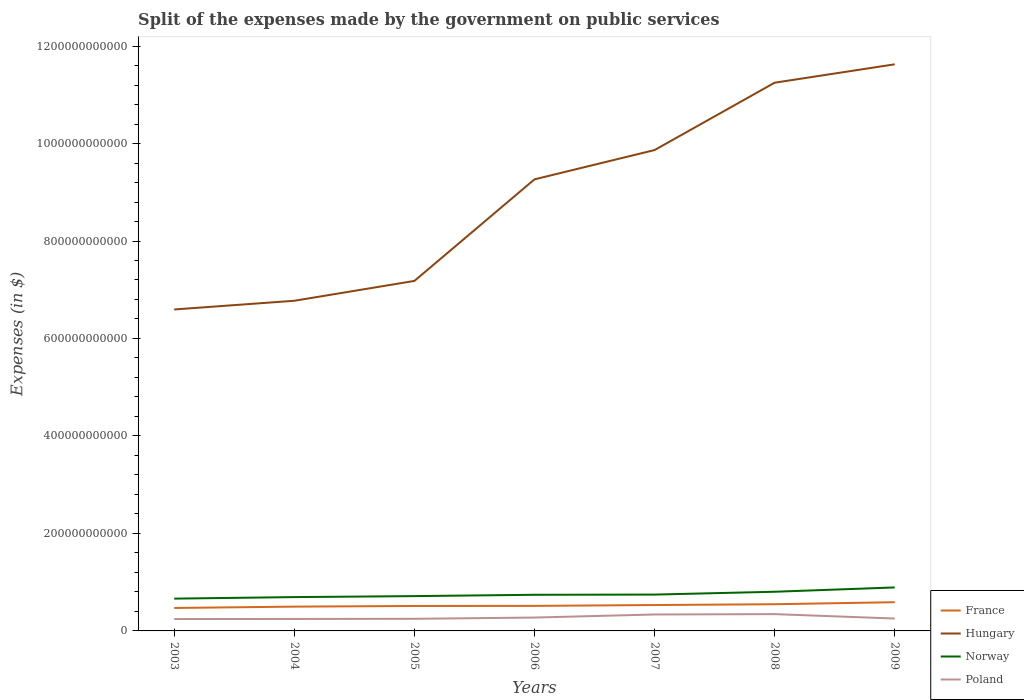Does the line corresponding to Norway intersect with the line corresponding to France?
Your answer should be compact. No. Is the number of lines equal to the number of legend labels?
Your answer should be compact. Yes. Across all years, what is the maximum expenses made by the government on public services in Hungary?
Your response must be concise. 6.60e+11. In which year was the expenses made by the government on public services in Hungary maximum?
Your answer should be very brief. 2003. What is the total expenses made by the government on public services in Poland in the graph?
Ensure brevity in your answer.  -9.18e+09. What is the difference between the highest and the second highest expenses made by the government on public services in France?
Your answer should be very brief. 1.18e+1. What is the difference between the highest and the lowest expenses made by the government on public services in Poland?
Your answer should be very brief. 2. Is the expenses made by the government on public services in Hungary strictly greater than the expenses made by the government on public services in France over the years?
Offer a very short reply. No. What is the difference between two consecutive major ticks on the Y-axis?
Offer a very short reply. 2.00e+11. Does the graph contain any zero values?
Provide a short and direct response. No. Does the graph contain grids?
Provide a short and direct response. No. Where does the legend appear in the graph?
Give a very brief answer. Bottom right. How many legend labels are there?
Your response must be concise. 4. What is the title of the graph?
Give a very brief answer. Split of the expenses made by the government on public services. What is the label or title of the X-axis?
Your response must be concise. Years. What is the label or title of the Y-axis?
Keep it short and to the point. Expenses (in $). What is the Expenses (in $) in France in 2003?
Ensure brevity in your answer.  4.71e+1. What is the Expenses (in $) of Hungary in 2003?
Provide a short and direct response. 6.60e+11. What is the Expenses (in $) of Norway in 2003?
Keep it short and to the point. 6.63e+1. What is the Expenses (in $) of Poland in 2003?
Ensure brevity in your answer.  2.44e+1. What is the Expenses (in $) in France in 2004?
Your answer should be very brief. 4.99e+1. What is the Expenses (in $) in Hungary in 2004?
Make the answer very short. 6.77e+11. What is the Expenses (in $) of Norway in 2004?
Ensure brevity in your answer.  6.94e+1. What is the Expenses (in $) in Poland in 2004?
Ensure brevity in your answer.  2.46e+1. What is the Expenses (in $) in France in 2005?
Give a very brief answer. 5.12e+1. What is the Expenses (in $) in Hungary in 2005?
Provide a succinct answer. 7.18e+11. What is the Expenses (in $) in Norway in 2005?
Ensure brevity in your answer.  7.14e+1. What is the Expenses (in $) in Poland in 2005?
Give a very brief answer. 2.49e+1. What is the Expenses (in $) in France in 2006?
Your response must be concise. 5.14e+1. What is the Expenses (in $) of Hungary in 2006?
Offer a terse response. 9.26e+11. What is the Expenses (in $) in Norway in 2006?
Provide a succinct answer. 7.42e+1. What is the Expenses (in $) of Poland in 2006?
Your answer should be compact. 2.74e+1. What is the Expenses (in $) in France in 2007?
Make the answer very short. 5.31e+1. What is the Expenses (in $) of Hungary in 2007?
Your answer should be very brief. 9.87e+11. What is the Expenses (in $) in Norway in 2007?
Your answer should be compact. 7.46e+1. What is the Expenses (in $) of Poland in 2007?
Provide a succinct answer. 3.37e+1. What is the Expenses (in $) of France in 2008?
Make the answer very short. 5.48e+1. What is the Expenses (in $) of Hungary in 2008?
Offer a terse response. 1.12e+12. What is the Expenses (in $) in Norway in 2008?
Your answer should be compact. 8.04e+1. What is the Expenses (in $) of Poland in 2008?
Offer a very short reply. 3.45e+1. What is the Expenses (in $) of France in 2009?
Offer a terse response. 5.89e+1. What is the Expenses (in $) in Hungary in 2009?
Your response must be concise. 1.16e+12. What is the Expenses (in $) of Norway in 2009?
Offer a terse response. 8.92e+1. What is the Expenses (in $) of Poland in 2009?
Give a very brief answer. 2.54e+1. Across all years, what is the maximum Expenses (in $) of France?
Provide a short and direct response. 5.89e+1. Across all years, what is the maximum Expenses (in $) of Hungary?
Give a very brief answer. 1.16e+12. Across all years, what is the maximum Expenses (in $) of Norway?
Offer a very short reply. 8.92e+1. Across all years, what is the maximum Expenses (in $) in Poland?
Make the answer very short. 3.45e+1. Across all years, what is the minimum Expenses (in $) of France?
Provide a succinct answer. 4.71e+1. Across all years, what is the minimum Expenses (in $) in Hungary?
Ensure brevity in your answer.  6.60e+11. Across all years, what is the minimum Expenses (in $) in Norway?
Ensure brevity in your answer.  6.63e+1. Across all years, what is the minimum Expenses (in $) of Poland?
Provide a short and direct response. 2.44e+1. What is the total Expenses (in $) in France in the graph?
Provide a succinct answer. 3.66e+11. What is the total Expenses (in $) in Hungary in the graph?
Your answer should be very brief. 6.26e+12. What is the total Expenses (in $) in Norway in the graph?
Your answer should be very brief. 5.25e+11. What is the total Expenses (in $) in Poland in the graph?
Provide a short and direct response. 1.95e+11. What is the difference between the Expenses (in $) of France in 2003 and that in 2004?
Provide a succinct answer. -2.75e+09. What is the difference between the Expenses (in $) of Hungary in 2003 and that in 2004?
Offer a very short reply. -1.79e+1. What is the difference between the Expenses (in $) of Norway in 2003 and that in 2004?
Your response must be concise. -3.13e+09. What is the difference between the Expenses (in $) of Poland in 2003 and that in 2004?
Your answer should be very brief. -1.78e+08. What is the difference between the Expenses (in $) in France in 2003 and that in 2005?
Your answer should be very brief. -4.07e+09. What is the difference between the Expenses (in $) in Hungary in 2003 and that in 2005?
Offer a very short reply. -5.86e+1. What is the difference between the Expenses (in $) in Norway in 2003 and that in 2005?
Provide a short and direct response. -5.14e+09. What is the difference between the Expenses (in $) of Poland in 2003 and that in 2005?
Ensure brevity in your answer.  -4.85e+08. What is the difference between the Expenses (in $) of France in 2003 and that in 2006?
Offer a terse response. -4.28e+09. What is the difference between the Expenses (in $) in Hungary in 2003 and that in 2006?
Offer a terse response. -2.67e+11. What is the difference between the Expenses (in $) of Norway in 2003 and that in 2006?
Offer a terse response. -7.88e+09. What is the difference between the Expenses (in $) of Poland in 2003 and that in 2006?
Offer a very short reply. -3.08e+09. What is the difference between the Expenses (in $) in France in 2003 and that in 2007?
Ensure brevity in your answer.  -6.01e+09. What is the difference between the Expenses (in $) in Hungary in 2003 and that in 2007?
Ensure brevity in your answer.  -3.27e+11. What is the difference between the Expenses (in $) of Norway in 2003 and that in 2007?
Ensure brevity in your answer.  -8.30e+09. What is the difference between the Expenses (in $) in Poland in 2003 and that in 2007?
Your response must be concise. -9.36e+09. What is the difference between the Expenses (in $) of France in 2003 and that in 2008?
Provide a succinct answer. -7.69e+09. What is the difference between the Expenses (in $) of Hungary in 2003 and that in 2008?
Give a very brief answer. -4.65e+11. What is the difference between the Expenses (in $) in Norway in 2003 and that in 2008?
Provide a short and direct response. -1.41e+1. What is the difference between the Expenses (in $) of Poland in 2003 and that in 2008?
Give a very brief answer. -1.01e+1. What is the difference between the Expenses (in $) of France in 2003 and that in 2009?
Your answer should be very brief. -1.18e+1. What is the difference between the Expenses (in $) in Hungary in 2003 and that in 2009?
Offer a very short reply. -5.03e+11. What is the difference between the Expenses (in $) of Norway in 2003 and that in 2009?
Your response must be concise. -2.30e+1. What is the difference between the Expenses (in $) in Poland in 2003 and that in 2009?
Provide a succinct answer. -1.05e+09. What is the difference between the Expenses (in $) in France in 2004 and that in 2005?
Ensure brevity in your answer.  -1.32e+09. What is the difference between the Expenses (in $) of Hungary in 2004 and that in 2005?
Offer a terse response. -4.07e+1. What is the difference between the Expenses (in $) of Norway in 2004 and that in 2005?
Provide a short and direct response. -2.02e+09. What is the difference between the Expenses (in $) of Poland in 2004 and that in 2005?
Keep it short and to the point. -3.07e+08. What is the difference between the Expenses (in $) of France in 2004 and that in 2006?
Your answer should be very brief. -1.53e+09. What is the difference between the Expenses (in $) of Hungary in 2004 and that in 2006?
Offer a very short reply. -2.49e+11. What is the difference between the Expenses (in $) in Norway in 2004 and that in 2006?
Your response must be concise. -4.76e+09. What is the difference between the Expenses (in $) of Poland in 2004 and that in 2006?
Provide a short and direct response. -2.90e+09. What is the difference between the Expenses (in $) in France in 2004 and that in 2007?
Make the answer very short. -3.26e+09. What is the difference between the Expenses (in $) in Hungary in 2004 and that in 2007?
Give a very brief answer. -3.09e+11. What is the difference between the Expenses (in $) in Norway in 2004 and that in 2007?
Offer a very short reply. -5.18e+09. What is the difference between the Expenses (in $) of Poland in 2004 and that in 2007?
Make the answer very short. -9.18e+09. What is the difference between the Expenses (in $) of France in 2004 and that in 2008?
Provide a succinct answer. -4.94e+09. What is the difference between the Expenses (in $) of Hungary in 2004 and that in 2008?
Ensure brevity in your answer.  -4.47e+11. What is the difference between the Expenses (in $) of Norway in 2004 and that in 2008?
Give a very brief answer. -1.10e+1. What is the difference between the Expenses (in $) of Poland in 2004 and that in 2008?
Your answer should be compact. -9.92e+09. What is the difference between the Expenses (in $) of France in 2004 and that in 2009?
Make the answer very short. -9.05e+09. What is the difference between the Expenses (in $) in Hungary in 2004 and that in 2009?
Your answer should be compact. -4.85e+11. What is the difference between the Expenses (in $) in Norway in 2004 and that in 2009?
Offer a very short reply. -1.98e+1. What is the difference between the Expenses (in $) of Poland in 2004 and that in 2009?
Ensure brevity in your answer.  -8.69e+08. What is the difference between the Expenses (in $) in France in 2005 and that in 2006?
Give a very brief answer. -2.12e+08. What is the difference between the Expenses (in $) in Hungary in 2005 and that in 2006?
Keep it short and to the point. -2.08e+11. What is the difference between the Expenses (in $) of Norway in 2005 and that in 2006?
Keep it short and to the point. -2.74e+09. What is the difference between the Expenses (in $) of Poland in 2005 and that in 2006?
Offer a very short reply. -2.59e+09. What is the difference between the Expenses (in $) of France in 2005 and that in 2007?
Your answer should be very brief. -1.94e+09. What is the difference between the Expenses (in $) of Hungary in 2005 and that in 2007?
Make the answer very short. -2.69e+11. What is the difference between the Expenses (in $) of Norway in 2005 and that in 2007?
Offer a terse response. -3.16e+09. What is the difference between the Expenses (in $) of Poland in 2005 and that in 2007?
Provide a short and direct response. -8.87e+09. What is the difference between the Expenses (in $) in France in 2005 and that in 2008?
Keep it short and to the point. -3.62e+09. What is the difference between the Expenses (in $) of Hungary in 2005 and that in 2008?
Make the answer very short. -4.07e+11. What is the difference between the Expenses (in $) in Norway in 2005 and that in 2008?
Offer a very short reply. -8.97e+09. What is the difference between the Expenses (in $) in Poland in 2005 and that in 2008?
Provide a succinct answer. -9.62e+09. What is the difference between the Expenses (in $) of France in 2005 and that in 2009?
Offer a terse response. -7.73e+09. What is the difference between the Expenses (in $) of Hungary in 2005 and that in 2009?
Provide a succinct answer. -4.44e+11. What is the difference between the Expenses (in $) of Norway in 2005 and that in 2009?
Make the answer very short. -1.78e+1. What is the difference between the Expenses (in $) of Poland in 2005 and that in 2009?
Ensure brevity in your answer.  -5.62e+08. What is the difference between the Expenses (in $) in France in 2006 and that in 2007?
Your answer should be compact. -1.73e+09. What is the difference between the Expenses (in $) of Hungary in 2006 and that in 2007?
Keep it short and to the point. -6.01e+1. What is the difference between the Expenses (in $) of Norway in 2006 and that in 2007?
Offer a terse response. -4.20e+08. What is the difference between the Expenses (in $) in Poland in 2006 and that in 2007?
Ensure brevity in your answer.  -6.28e+09. What is the difference between the Expenses (in $) in France in 2006 and that in 2008?
Keep it short and to the point. -3.41e+09. What is the difference between the Expenses (in $) in Hungary in 2006 and that in 2008?
Keep it short and to the point. -1.98e+11. What is the difference between the Expenses (in $) in Norway in 2006 and that in 2008?
Keep it short and to the point. -6.23e+09. What is the difference between the Expenses (in $) of Poland in 2006 and that in 2008?
Your answer should be compact. -7.02e+09. What is the difference between the Expenses (in $) of France in 2006 and that in 2009?
Offer a terse response. -7.52e+09. What is the difference between the Expenses (in $) in Hungary in 2006 and that in 2009?
Make the answer very short. -2.36e+11. What is the difference between the Expenses (in $) of Norway in 2006 and that in 2009?
Provide a short and direct response. -1.51e+1. What is the difference between the Expenses (in $) of Poland in 2006 and that in 2009?
Your response must be concise. 2.03e+09. What is the difference between the Expenses (in $) of France in 2007 and that in 2008?
Your answer should be compact. -1.68e+09. What is the difference between the Expenses (in $) in Hungary in 2007 and that in 2008?
Ensure brevity in your answer.  -1.38e+11. What is the difference between the Expenses (in $) of Norway in 2007 and that in 2008?
Your response must be concise. -5.81e+09. What is the difference between the Expenses (in $) of Poland in 2007 and that in 2008?
Your answer should be very brief. -7.43e+08. What is the difference between the Expenses (in $) in France in 2007 and that in 2009?
Make the answer very short. -5.79e+09. What is the difference between the Expenses (in $) in Hungary in 2007 and that in 2009?
Offer a very short reply. -1.76e+11. What is the difference between the Expenses (in $) of Norway in 2007 and that in 2009?
Offer a very short reply. -1.47e+1. What is the difference between the Expenses (in $) in Poland in 2007 and that in 2009?
Offer a terse response. 8.31e+09. What is the difference between the Expenses (in $) of France in 2008 and that in 2009?
Offer a very short reply. -4.11e+09. What is the difference between the Expenses (in $) in Hungary in 2008 and that in 2009?
Provide a short and direct response. -3.77e+1. What is the difference between the Expenses (in $) of Norway in 2008 and that in 2009?
Offer a terse response. -8.85e+09. What is the difference between the Expenses (in $) in Poland in 2008 and that in 2009?
Your answer should be compact. 9.05e+09. What is the difference between the Expenses (in $) in France in 2003 and the Expenses (in $) in Hungary in 2004?
Your answer should be compact. -6.30e+11. What is the difference between the Expenses (in $) of France in 2003 and the Expenses (in $) of Norway in 2004?
Your answer should be very brief. -2.23e+1. What is the difference between the Expenses (in $) in France in 2003 and the Expenses (in $) in Poland in 2004?
Offer a very short reply. 2.26e+1. What is the difference between the Expenses (in $) of Hungary in 2003 and the Expenses (in $) of Norway in 2004?
Offer a terse response. 5.90e+11. What is the difference between the Expenses (in $) of Hungary in 2003 and the Expenses (in $) of Poland in 2004?
Provide a short and direct response. 6.35e+11. What is the difference between the Expenses (in $) of Norway in 2003 and the Expenses (in $) of Poland in 2004?
Provide a short and direct response. 4.17e+1. What is the difference between the Expenses (in $) in France in 2003 and the Expenses (in $) in Hungary in 2005?
Offer a terse response. -6.71e+11. What is the difference between the Expenses (in $) of France in 2003 and the Expenses (in $) of Norway in 2005?
Your response must be concise. -2.43e+1. What is the difference between the Expenses (in $) in France in 2003 and the Expenses (in $) in Poland in 2005?
Your answer should be compact. 2.22e+1. What is the difference between the Expenses (in $) in Hungary in 2003 and the Expenses (in $) in Norway in 2005?
Your response must be concise. 5.88e+11. What is the difference between the Expenses (in $) of Hungary in 2003 and the Expenses (in $) of Poland in 2005?
Your answer should be very brief. 6.35e+11. What is the difference between the Expenses (in $) in Norway in 2003 and the Expenses (in $) in Poland in 2005?
Provide a succinct answer. 4.14e+1. What is the difference between the Expenses (in $) in France in 2003 and the Expenses (in $) in Hungary in 2006?
Give a very brief answer. -8.79e+11. What is the difference between the Expenses (in $) in France in 2003 and the Expenses (in $) in Norway in 2006?
Keep it short and to the point. -2.70e+1. What is the difference between the Expenses (in $) of France in 2003 and the Expenses (in $) of Poland in 2006?
Make the answer very short. 1.97e+1. What is the difference between the Expenses (in $) in Hungary in 2003 and the Expenses (in $) in Norway in 2006?
Keep it short and to the point. 5.85e+11. What is the difference between the Expenses (in $) of Hungary in 2003 and the Expenses (in $) of Poland in 2006?
Your response must be concise. 6.32e+11. What is the difference between the Expenses (in $) in Norway in 2003 and the Expenses (in $) in Poland in 2006?
Provide a short and direct response. 3.88e+1. What is the difference between the Expenses (in $) of France in 2003 and the Expenses (in $) of Hungary in 2007?
Provide a succinct answer. -9.39e+11. What is the difference between the Expenses (in $) of France in 2003 and the Expenses (in $) of Norway in 2007?
Make the answer very short. -2.75e+1. What is the difference between the Expenses (in $) in France in 2003 and the Expenses (in $) in Poland in 2007?
Make the answer very short. 1.34e+1. What is the difference between the Expenses (in $) of Hungary in 2003 and the Expenses (in $) of Norway in 2007?
Offer a very short reply. 5.85e+11. What is the difference between the Expenses (in $) of Hungary in 2003 and the Expenses (in $) of Poland in 2007?
Ensure brevity in your answer.  6.26e+11. What is the difference between the Expenses (in $) of Norway in 2003 and the Expenses (in $) of Poland in 2007?
Your answer should be very brief. 3.25e+1. What is the difference between the Expenses (in $) in France in 2003 and the Expenses (in $) in Hungary in 2008?
Your response must be concise. -1.08e+12. What is the difference between the Expenses (in $) in France in 2003 and the Expenses (in $) in Norway in 2008?
Ensure brevity in your answer.  -3.33e+1. What is the difference between the Expenses (in $) in France in 2003 and the Expenses (in $) in Poland in 2008?
Your answer should be compact. 1.26e+1. What is the difference between the Expenses (in $) of Hungary in 2003 and the Expenses (in $) of Norway in 2008?
Your response must be concise. 5.79e+11. What is the difference between the Expenses (in $) in Hungary in 2003 and the Expenses (in $) in Poland in 2008?
Your answer should be compact. 6.25e+11. What is the difference between the Expenses (in $) of Norway in 2003 and the Expenses (in $) of Poland in 2008?
Your answer should be very brief. 3.18e+1. What is the difference between the Expenses (in $) in France in 2003 and the Expenses (in $) in Hungary in 2009?
Your response must be concise. -1.12e+12. What is the difference between the Expenses (in $) in France in 2003 and the Expenses (in $) in Norway in 2009?
Your answer should be very brief. -4.21e+1. What is the difference between the Expenses (in $) in France in 2003 and the Expenses (in $) in Poland in 2009?
Provide a short and direct response. 2.17e+1. What is the difference between the Expenses (in $) of Hungary in 2003 and the Expenses (in $) of Norway in 2009?
Give a very brief answer. 5.70e+11. What is the difference between the Expenses (in $) in Hungary in 2003 and the Expenses (in $) in Poland in 2009?
Ensure brevity in your answer.  6.34e+11. What is the difference between the Expenses (in $) of Norway in 2003 and the Expenses (in $) of Poland in 2009?
Your answer should be compact. 4.08e+1. What is the difference between the Expenses (in $) of France in 2004 and the Expenses (in $) of Hungary in 2005?
Keep it short and to the point. -6.68e+11. What is the difference between the Expenses (in $) of France in 2004 and the Expenses (in $) of Norway in 2005?
Provide a short and direct response. -2.16e+1. What is the difference between the Expenses (in $) in France in 2004 and the Expenses (in $) in Poland in 2005?
Make the answer very short. 2.50e+1. What is the difference between the Expenses (in $) of Hungary in 2004 and the Expenses (in $) of Norway in 2005?
Ensure brevity in your answer.  6.06e+11. What is the difference between the Expenses (in $) in Hungary in 2004 and the Expenses (in $) in Poland in 2005?
Provide a short and direct response. 6.53e+11. What is the difference between the Expenses (in $) in Norway in 2004 and the Expenses (in $) in Poland in 2005?
Make the answer very short. 4.45e+1. What is the difference between the Expenses (in $) in France in 2004 and the Expenses (in $) in Hungary in 2006?
Ensure brevity in your answer.  -8.77e+11. What is the difference between the Expenses (in $) in France in 2004 and the Expenses (in $) in Norway in 2006?
Keep it short and to the point. -2.43e+1. What is the difference between the Expenses (in $) of France in 2004 and the Expenses (in $) of Poland in 2006?
Provide a succinct answer. 2.24e+1. What is the difference between the Expenses (in $) in Hungary in 2004 and the Expenses (in $) in Norway in 2006?
Keep it short and to the point. 6.03e+11. What is the difference between the Expenses (in $) in Hungary in 2004 and the Expenses (in $) in Poland in 2006?
Give a very brief answer. 6.50e+11. What is the difference between the Expenses (in $) in Norway in 2004 and the Expenses (in $) in Poland in 2006?
Ensure brevity in your answer.  4.19e+1. What is the difference between the Expenses (in $) in France in 2004 and the Expenses (in $) in Hungary in 2007?
Your answer should be very brief. -9.37e+11. What is the difference between the Expenses (in $) in France in 2004 and the Expenses (in $) in Norway in 2007?
Your response must be concise. -2.47e+1. What is the difference between the Expenses (in $) of France in 2004 and the Expenses (in $) of Poland in 2007?
Your answer should be compact. 1.61e+1. What is the difference between the Expenses (in $) of Hungary in 2004 and the Expenses (in $) of Norway in 2007?
Keep it short and to the point. 6.03e+11. What is the difference between the Expenses (in $) of Hungary in 2004 and the Expenses (in $) of Poland in 2007?
Make the answer very short. 6.44e+11. What is the difference between the Expenses (in $) of Norway in 2004 and the Expenses (in $) of Poland in 2007?
Your answer should be compact. 3.57e+1. What is the difference between the Expenses (in $) in France in 2004 and the Expenses (in $) in Hungary in 2008?
Offer a very short reply. -1.07e+12. What is the difference between the Expenses (in $) of France in 2004 and the Expenses (in $) of Norway in 2008?
Provide a short and direct response. -3.05e+1. What is the difference between the Expenses (in $) in France in 2004 and the Expenses (in $) in Poland in 2008?
Give a very brief answer. 1.54e+1. What is the difference between the Expenses (in $) in Hungary in 2004 and the Expenses (in $) in Norway in 2008?
Offer a very short reply. 5.97e+11. What is the difference between the Expenses (in $) in Hungary in 2004 and the Expenses (in $) in Poland in 2008?
Provide a succinct answer. 6.43e+11. What is the difference between the Expenses (in $) of Norway in 2004 and the Expenses (in $) of Poland in 2008?
Provide a succinct answer. 3.49e+1. What is the difference between the Expenses (in $) of France in 2004 and the Expenses (in $) of Hungary in 2009?
Give a very brief answer. -1.11e+12. What is the difference between the Expenses (in $) of France in 2004 and the Expenses (in $) of Norway in 2009?
Offer a terse response. -3.94e+1. What is the difference between the Expenses (in $) of France in 2004 and the Expenses (in $) of Poland in 2009?
Give a very brief answer. 2.44e+1. What is the difference between the Expenses (in $) in Hungary in 2004 and the Expenses (in $) in Norway in 2009?
Ensure brevity in your answer.  5.88e+11. What is the difference between the Expenses (in $) of Hungary in 2004 and the Expenses (in $) of Poland in 2009?
Offer a terse response. 6.52e+11. What is the difference between the Expenses (in $) of Norway in 2004 and the Expenses (in $) of Poland in 2009?
Provide a succinct answer. 4.40e+1. What is the difference between the Expenses (in $) of France in 2005 and the Expenses (in $) of Hungary in 2006?
Offer a terse response. -8.75e+11. What is the difference between the Expenses (in $) in France in 2005 and the Expenses (in $) in Norway in 2006?
Offer a very short reply. -2.30e+1. What is the difference between the Expenses (in $) in France in 2005 and the Expenses (in $) in Poland in 2006?
Offer a terse response. 2.37e+1. What is the difference between the Expenses (in $) of Hungary in 2005 and the Expenses (in $) of Norway in 2006?
Provide a succinct answer. 6.44e+11. What is the difference between the Expenses (in $) of Hungary in 2005 and the Expenses (in $) of Poland in 2006?
Provide a succinct answer. 6.91e+11. What is the difference between the Expenses (in $) in Norway in 2005 and the Expenses (in $) in Poland in 2006?
Provide a succinct answer. 4.40e+1. What is the difference between the Expenses (in $) of France in 2005 and the Expenses (in $) of Hungary in 2007?
Ensure brevity in your answer.  -9.35e+11. What is the difference between the Expenses (in $) of France in 2005 and the Expenses (in $) of Norway in 2007?
Your answer should be compact. -2.34e+1. What is the difference between the Expenses (in $) in France in 2005 and the Expenses (in $) in Poland in 2007?
Your response must be concise. 1.74e+1. What is the difference between the Expenses (in $) of Hungary in 2005 and the Expenses (in $) of Norway in 2007?
Your answer should be very brief. 6.44e+11. What is the difference between the Expenses (in $) in Hungary in 2005 and the Expenses (in $) in Poland in 2007?
Give a very brief answer. 6.84e+11. What is the difference between the Expenses (in $) in Norway in 2005 and the Expenses (in $) in Poland in 2007?
Offer a terse response. 3.77e+1. What is the difference between the Expenses (in $) of France in 2005 and the Expenses (in $) of Hungary in 2008?
Offer a terse response. -1.07e+12. What is the difference between the Expenses (in $) in France in 2005 and the Expenses (in $) in Norway in 2008?
Make the answer very short. -2.92e+1. What is the difference between the Expenses (in $) of France in 2005 and the Expenses (in $) of Poland in 2008?
Make the answer very short. 1.67e+1. What is the difference between the Expenses (in $) in Hungary in 2005 and the Expenses (in $) in Norway in 2008?
Provide a succinct answer. 6.38e+11. What is the difference between the Expenses (in $) of Hungary in 2005 and the Expenses (in $) of Poland in 2008?
Offer a terse response. 6.84e+11. What is the difference between the Expenses (in $) of Norway in 2005 and the Expenses (in $) of Poland in 2008?
Offer a very short reply. 3.69e+1. What is the difference between the Expenses (in $) of France in 2005 and the Expenses (in $) of Hungary in 2009?
Offer a terse response. -1.11e+12. What is the difference between the Expenses (in $) of France in 2005 and the Expenses (in $) of Norway in 2009?
Keep it short and to the point. -3.81e+1. What is the difference between the Expenses (in $) of France in 2005 and the Expenses (in $) of Poland in 2009?
Keep it short and to the point. 2.58e+1. What is the difference between the Expenses (in $) in Hungary in 2005 and the Expenses (in $) in Norway in 2009?
Your answer should be very brief. 6.29e+11. What is the difference between the Expenses (in $) in Hungary in 2005 and the Expenses (in $) in Poland in 2009?
Your answer should be compact. 6.93e+11. What is the difference between the Expenses (in $) of Norway in 2005 and the Expenses (in $) of Poland in 2009?
Your answer should be very brief. 4.60e+1. What is the difference between the Expenses (in $) of France in 2006 and the Expenses (in $) of Hungary in 2007?
Give a very brief answer. -9.35e+11. What is the difference between the Expenses (in $) in France in 2006 and the Expenses (in $) in Norway in 2007?
Provide a succinct answer. -2.32e+1. What is the difference between the Expenses (in $) of France in 2006 and the Expenses (in $) of Poland in 2007?
Your answer should be very brief. 1.77e+1. What is the difference between the Expenses (in $) in Hungary in 2006 and the Expenses (in $) in Norway in 2007?
Your answer should be compact. 8.52e+11. What is the difference between the Expenses (in $) of Hungary in 2006 and the Expenses (in $) of Poland in 2007?
Make the answer very short. 8.93e+11. What is the difference between the Expenses (in $) of Norway in 2006 and the Expenses (in $) of Poland in 2007?
Provide a succinct answer. 4.04e+1. What is the difference between the Expenses (in $) in France in 2006 and the Expenses (in $) in Hungary in 2008?
Give a very brief answer. -1.07e+12. What is the difference between the Expenses (in $) in France in 2006 and the Expenses (in $) in Norway in 2008?
Offer a terse response. -2.90e+1. What is the difference between the Expenses (in $) of France in 2006 and the Expenses (in $) of Poland in 2008?
Provide a succinct answer. 1.69e+1. What is the difference between the Expenses (in $) in Hungary in 2006 and the Expenses (in $) in Norway in 2008?
Provide a short and direct response. 8.46e+11. What is the difference between the Expenses (in $) of Hungary in 2006 and the Expenses (in $) of Poland in 2008?
Make the answer very short. 8.92e+11. What is the difference between the Expenses (in $) in Norway in 2006 and the Expenses (in $) in Poland in 2008?
Offer a very short reply. 3.97e+1. What is the difference between the Expenses (in $) of France in 2006 and the Expenses (in $) of Hungary in 2009?
Your answer should be very brief. -1.11e+12. What is the difference between the Expenses (in $) of France in 2006 and the Expenses (in $) of Norway in 2009?
Your answer should be very brief. -3.78e+1. What is the difference between the Expenses (in $) in France in 2006 and the Expenses (in $) in Poland in 2009?
Keep it short and to the point. 2.60e+1. What is the difference between the Expenses (in $) of Hungary in 2006 and the Expenses (in $) of Norway in 2009?
Give a very brief answer. 8.37e+11. What is the difference between the Expenses (in $) in Hungary in 2006 and the Expenses (in $) in Poland in 2009?
Provide a short and direct response. 9.01e+11. What is the difference between the Expenses (in $) in Norway in 2006 and the Expenses (in $) in Poland in 2009?
Offer a terse response. 4.87e+1. What is the difference between the Expenses (in $) of France in 2007 and the Expenses (in $) of Hungary in 2008?
Ensure brevity in your answer.  -1.07e+12. What is the difference between the Expenses (in $) in France in 2007 and the Expenses (in $) in Norway in 2008?
Keep it short and to the point. -2.73e+1. What is the difference between the Expenses (in $) in France in 2007 and the Expenses (in $) in Poland in 2008?
Ensure brevity in your answer.  1.86e+1. What is the difference between the Expenses (in $) of Hungary in 2007 and the Expenses (in $) of Norway in 2008?
Keep it short and to the point. 9.06e+11. What is the difference between the Expenses (in $) of Hungary in 2007 and the Expenses (in $) of Poland in 2008?
Ensure brevity in your answer.  9.52e+11. What is the difference between the Expenses (in $) of Norway in 2007 and the Expenses (in $) of Poland in 2008?
Make the answer very short. 4.01e+1. What is the difference between the Expenses (in $) in France in 2007 and the Expenses (in $) in Hungary in 2009?
Provide a short and direct response. -1.11e+12. What is the difference between the Expenses (in $) of France in 2007 and the Expenses (in $) of Norway in 2009?
Offer a terse response. -3.61e+1. What is the difference between the Expenses (in $) in France in 2007 and the Expenses (in $) in Poland in 2009?
Your answer should be compact. 2.77e+1. What is the difference between the Expenses (in $) of Hungary in 2007 and the Expenses (in $) of Norway in 2009?
Ensure brevity in your answer.  8.97e+11. What is the difference between the Expenses (in $) in Hungary in 2007 and the Expenses (in $) in Poland in 2009?
Your answer should be compact. 9.61e+11. What is the difference between the Expenses (in $) of Norway in 2007 and the Expenses (in $) of Poland in 2009?
Ensure brevity in your answer.  4.92e+1. What is the difference between the Expenses (in $) of France in 2008 and the Expenses (in $) of Hungary in 2009?
Offer a terse response. -1.11e+12. What is the difference between the Expenses (in $) in France in 2008 and the Expenses (in $) in Norway in 2009?
Offer a very short reply. -3.44e+1. What is the difference between the Expenses (in $) in France in 2008 and the Expenses (in $) in Poland in 2009?
Offer a very short reply. 2.94e+1. What is the difference between the Expenses (in $) in Hungary in 2008 and the Expenses (in $) in Norway in 2009?
Your response must be concise. 1.04e+12. What is the difference between the Expenses (in $) in Hungary in 2008 and the Expenses (in $) in Poland in 2009?
Your answer should be compact. 1.10e+12. What is the difference between the Expenses (in $) in Norway in 2008 and the Expenses (in $) in Poland in 2009?
Give a very brief answer. 5.50e+1. What is the average Expenses (in $) of France per year?
Your answer should be very brief. 5.23e+1. What is the average Expenses (in $) in Hungary per year?
Your answer should be compact. 8.94e+11. What is the average Expenses (in $) in Norway per year?
Make the answer very short. 7.51e+1. What is the average Expenses (in $) of Poland per year?
Give a very brief answer. 2.78e+1. In the year 2003, what is the difference between the Expenses (in $) in France and Expenses (in $) in Hungary?
Offer a terse response. -6.12e+11. In the year 2003, what is the difference between the Expenses (in $) in France and Expenses (in $) in Norway?
Provide a short and direct response. -1.92e+1. In the year 2003, what is the difference between the Expenses (in $) of France and Expenses (in $) of Poland?
Offer a very short reply. 2.27e+1. In the year 2003, what is the difference between the Expenses (in $) in Hungary and Expenses (in $) in Norway?
Your answer should be compact. 5.93e+11. In the year 2003, what is the difference between the Expenses (in $) of Hungary and Expenses (in $) of Poland?
Make the answer very short. 6.35e+11. In the year 2003, what is the difference between the Expenses (in $) of Norway and Expenses (in $) of Poland?
Provide a succinct answer. 4.19e+1. In the year 2004, what is the difference between the Expenses (in $) of France and Expenses (in $) of Hungary?
Give a very brief answer. -6.28e+11. In the year 2004, what is the difference between the Expenses (in $) in France and Expenses (in $) in Norway?
Provide a short and direct response. -1.95e+1. In the year 2004, what is the difference between the Expenses (in $) of France and Expenses (in $) of Poland?
Your answer should be very brief. 2.53e+1. In the year 2004, what is the difference between the Expenses (in $) of Hungary and Expenses (in $) of Norway?
Offer a very short reply. 6.08e+11. In the year 2004, what is the difference between the Expenses (in $) of Hungary and Expenses (in $) of Poland?
Your response must be concise. 6.53e+11. In the year 2004, what is the difference between the Expenses (in $) in Norway and Expenses (in $) in Poland?
Offer a terse response. 4.48e+1. In the year 2005, what is the difference between the Expenses (in $) of France and Expenses (in $) of Hungary?
Your answer should be compact. -6.67e+11. In the year 2005, what is the difference between the Expenses (in $) of France and Expenses (in $) of Norway?
Offer a very short reply. -2.02e+1. In the year 2005, what is the difference between the Expenses (in $) of France and Expenses (in $) of Poland?
Provide a succinct answer. 2.63e+1. In the year 2005, what is the difference between the Expenses (in $) of Hungary and Expenses (in $) of Norway?
Provide a short and direct response. 6.47e+11. In the year 2005, what is the difference between the Expenses (in $) of Hungary and Expenses (in $) of Poland?
Provide a short and direct response. 6.93e+11. In the year 2005, what is the difference between the Expenses (in $) in Norway and Expenses (in $) in Poland?
Keep it short and to the point. 4.66e+1. In the year 2006, what is the difference between the Expenses (in $) of France and Expenses (in $) of Hungary?
Your response must be concise. -8.75e+11. In the year 2006, what is the difference between the Expenses (in $) in France and Expenses (in $) in Norway?
Make the answer very short. -2.28e+1. In the year 2006, what is the difference between the Expenses (in $) in France and Expenses (in $) in Poland?
Provide a succinct answer. 2.39e+1. In the year 2006, what is the difference between the Expenses (in $) in Hungary and Expenses (in $) in Norway?
Provide a short and direct response. 8.52e+11. In the year 2006, what is the difference between the Expenses (in $) in Hungary and Expenses (in $) in Poland?
Your response must be concise. 8.99e+11. In the year 2006, what is the difference between the Expenses (in $) of Norway and Expenses (in $) of Poland?
Provide a succinct answer. 4.67e+1. In the year 2007, what is the difference between the Expenses (in $) in France and Expenses (in $) in Hungary?
Offer a very short reply. -9.33e+11. In the year 2007, what is the difference between the Expenses (in $) of France and Expenses (in $) of Norway?
Your answer should be very brief. -2.15e+1. In the year 2007, what is the difference between the Expenses (in $) in France and Expenses (in $) in Poland?
Keep it short and to the point. 1.94e+1. In the year 2007, what is the difference between the Expenses (in $) in Hungary and Expenses (in $) in Norway?
Your answer should be compact. 9.12e+11. In the year 2007, what is the difference between the Expenses (in $) of Hungary and Expenses (in $) of Poland?
Your answer should be very brief. 9.53e+11. In the year 2007, what is the difference between the Expenses (in $) in Norway and Expenses (in $) in Poland?
Offer a terse response. 4.08e+1. In the year 2008, what is the difference between the Expenses (in $) of France and Expenses (in $) of Hungary?
Ensure brevity in your answer.  -1.07e+12. In the year 2008, what is the difference between the Expenses (in $) of France and Expenses (in $) of Norway?
Offer a terse response. -2.56e+1. In the year 2008, what is the difference between the Expenses (in $) of France and Expenses (in $) of Poland?
Ensure brevity in your answer.  2.03e+1. In the year 2008, what is the difference between the Expenses (in $) of Hungary and Expenses (in $) of Norway?
Keep it short and to the point. 1.04e+12. In the year 2008, what is the difference between the Expenses (in $) in Hungary and Expenses (in $) in Poland?
Offer a very short reply. 1.09e+12. In the year 2008, what is the difference between the Expenses (in $) in Norway and Expenses (in $) in Poland?
Offer a very short reply. 4.59e+1. In the year 2009, what is the difference between the Expenses (in $) of France and Expenses (in $) of Hungary?
Provide a succinct answer. -1.10e+12. In the year 2009, what is the difference between the Expenses (in $) in France and Expenses (in $) in Norway?
Your response must be concise. -3.03e+1. In the year 2009, what is the difference between the Expenses (in $) in France and Expenses (in $) in Poland?
Your response must be concise. 3.35e+1. In the year 2009, what is the difference between the Expenses (in $) in Hungary and Expenses (in $) in Norway?
Provide a succinct answer. 1.07e+12. In the year 2009, what is the difference between the Expenses (in $) in Hungary and Expenses (in $) in Poland?
Offer a very short reply. 1.14e+12. In the year 2009, what is the difference between the Expenses (in $) of Norway and Expenses (in $) of Poland?
Give a very brief answer. 6.38e+1. What is the ratio of the Expenses (in $) in France in 2003 to that in 2004?
Provide a short and direct response. 0.94. What is the ratio of the Expenses (in $) of Hungary in 2003 to that in 2004?
Provide a short and direct response. 0.97. What is the ratio of the Expenses (in $) of Norway in 2003 to that in 2004?
Offer a very short reply. 0.95. What is the ratio of the Expenses (in $) of Poland in 2003 to that in 2004?
Make the answer very short. 0.99. What is the ratio of the Expenses (in $) in France in 2003 to that in 2005?
Keep it short and to the point. 0.92. What is the ratio of the Expenses (in $) of Hungary in 2003 to that in 2005?
Your answer should be compact. 0.92. What is the ratio of the Expenses (in $) in Norway in 2003 to that in 2005?
Keep it short and to the point. 0.93. What is the ratio of the Expenses (in $) of Poland in 2003 to that in 2005?
Your answer should be very brief. 0.98. What is the ratio of the Expenses (in $) of Hungary in 2003 to that in 2006?
Offer a terse response. 0.71. What is the ratio of the Expenses (in $) of Norway in 2003 to that in 2006?
Offer a very short reply. 0.89. What is the ratio of the Expenses (in $) of Poland in 2003 to that in 2006?
Offer a very short reply. 0.89. What is the ratio of the Expenses (in $) in France in 2003 to that in 2007?
Provide a succinct answer. 0.89. What is the ratio of the Expenses (in $) in Hungary in 2003 to that in 2007?
Provide a succinct answer. 0.67. What is the ratio of the Expenses (in $) in Norway in 2003 to that in 2007?
Ensure brevity in your answer.  0.89. What is the ratio of the Expenses (in $) in Poland in 2003 to that in 2007?
Offer a terse response. 0.72. What is the ratio of the Expenses (in $) in France in 2003 to that in 2008?
Make the answer very short. 0.86. What is the ratio of the Expenses (in $) of Hungary in 2003 to that in 2008?
Give a very brief answer. 0.59. What is the ratio of the Expenses (in $) of Norway in 2003 to that in 2008?
Ensure brevity in your answer.  0.82. What is the ratio of the Expenses (in $) of Poland in 2003 to that in 2008?
Your response must be concise. 0.71. What is the ratio of the Expenses (in $) of France in 2003 to that in 2009?
Ensure brevity in your answer.  0.8. What is the ratio of the Expenses (in $) of Hungary in 2003 to that in 2009?
Give a very brief answer. 0.57. What is the ratio of the Expenses (in $) in Norway in 2003 to that in 2009?
Keep it short and to the point. 0.74. What is the ratio of the Expenses (in $) of Poland in 2003 to that in 2009?
Provide a short and direct response. 0.96. What is the ratio of the Expenses (in $) in France in 2004 to that in 2005?
Your answer should be compact. 0.97. What is the ratio of the Expenses (in $) of Hungary in 2004 to that in 2005?
Offer a terse response. 0.94. What is the ratio of the Expenses (in $) of Norway in 2004 to that in 2005?
Provide a short and direct response. 0.97. What is the ratio of the Expenses (in $) in Poland in 2004 to that in 2005?
Your answer should be very brief. 0.99. What is the ratio of the Expenses (in $) of France in 2004 to that in 2006?
Your response must be concise. 0.97. What is the ratio of the Expenses (in $) of Hungary in 2004 to that in 2006?
Your answer should be very brief. 0.73. What is the ratio of the Expenses (in $) in Norway in 2004 to that in 2006?
Offer a terse response. 0.94. What is the ratio of the Expenses (in $) of Poland in 2004 to that in 2006?
Ensure brevity in your answer.  0.89. What is the ratio of the Expenses (in $) in France in 2004 to that in 2007?
Your answer should be compact. 0.94. What is the ratio of the Expenses (in $) of Hungary in 2004 to that in 2007?
Your answer should be very brief. 0.69. What is the ratio of the Expenses (in $) in Norway in 2004 to that in 2007?
Provide a succinct answer. 0.93. What is the ratio of the Expenses (in $) of Poland in 2004 to that in 2007?
Ensure brevity in your answer.  0.73. What is the ratio of the Expenses (in $) of France in 2004 to that in 2008?
Your answer should be compact. 0.91. What is the ratio of the Expenses (in $) in Hungary in 2004 to that in 2008?
Your answer should be compact. 0.6. What is the ratio of the Expenses (in $) of Norway in 2004 to that in 2008?
Offer a very short reply. 0.86. What is the ratio of the Expenses (in $) in Poland in 2004 to that in 2008?
Ensure brevity in your answer.  0.71. What is the ratio of the Expenses (in $) in France in 2004 to that in 2009?
Give a very brief answer. 0.85. What is the ratio of the Expenses (in $) of Hungary in 2004 to that in 2009?
Keep it short and to the point. 0.58. What is the ratio of the Expenses (in $) of Norway in 2004 to that in 2009?
Offer a very short reply. 0.78. What is the ratio of the Expenses (in $) of Poland in 2004 to that in 2009?
Your answer should be very brief. 0.97. What is the ratio of the Expenses (in $) in France in 2005 to that in 2006?
Your answer should be very brief. 1. What is the ratio of the Expenses (in $) of Hungary in 2005 to that in 2006?
Provide a short and direct response. 0.78. What is the ratio of the Expenses (in $) in Norway in 2005 to that in 2006?
Keep it short and to the point. 0.96. What is the ratio of the Expenses (in $) in Poland in 2005 to that in 2006?
Your answer should be very brief. 0.91. What is the ratio of the Expenses (in $) of France in 2005 to that in 2007?
Your answer should be very brief. 0.96. What is the ratio of the Expenses (in $) in Hungary in 2005 to that in 2007?
Offer a very short reply. 0.73. What is the ratio of the Expenses (in $) in Norway in 2005 to that in 2007?
Provide a succinct answer. 0.96. What is the ratio of the Expenses (in $) of Poland in 2005 to that in 2007?
Offer a very short reply. 0.74. What is the ratio of the Expenses (in $) in France in 2005 to that in 2008?
Make the answer very short. 0.93. What is the ratio of the Expenses (in $) of Hungary in 2005 to that in 2008?
Offer a terse response. 0.64. What is the ratio of the Expenses (in $) in Norway in 2005 to that in 2008?
Your answer should be compact. 0.89. What is the ratio of the Expenses (in $) of Poland in 2005 to that in 2008?
Provide a short and direct response. 0.72. What is the ratio of the Expenses (in $) of France in 2005 to that in 2009?
Provide a short and direct response. 0.87. What is the ratio of the Expenses (in $) of Hungary in 2005 to that in 2009?
Your response must be concise. 0.62. What is the ratio of the Expenses (in $) of Norway in 2005 to that in 2009?
Your answer should be compact. 0.8. What is the ratio of the Expenses (in $) of Poland in 2005 to that in 2009?
Keep it short and to the point. 0.98. What is the ratio of the Expenses (in $) in France in 2006 to that in 2007?
Keep it short and to the point. 0.97. What is the ratio of the Expenses (in $) in Hungary in 2006 to that in 2007?
Make the answer very short. 0.94. What is the ratio of the Expenses (in $) in Norway in 2006 to that in 2007?
Provide a succinct answer. 0.99. What is the ratio of the Expenses (in $) of Poland in 2006 to that in 2007?
Give a very brief answer. 0.81. What is the ratio of the Expenses (in $) of France in 2006 to that in 2008?
Offer a very short reply. 0.94. What is the ratio of the Expenses (in $) in Hungary in 2006 to that in 2008?
Offer a very short reply. 0.82. What is the ratio of the Expenses (in $) in Norway in 2006 to that in 2008?
Keep it short and to the point. 0.92. What is the ratio of the Expenses (in $) of Poland in 2006 to that in 2008?
Offer a very short reply. 0.8. What is the ratio of the Expenses (in $) of France in 2006 to that in 2009?
Give a very brief answer. 0.87. What is the ratio of the Expenses (in $) of Hungary in 2006 to that in 2009?
Your answer should be compact. 0.8. What is the ratio of the Expenses (in $) of Norway in 2006 to that in 2009?
Give a very brief answer. 0.83. What is the ratio of the Expenses (in $) in Poland in 2006 to that in 2009?
Provide a succinct answer. 1.08. What is the ratio of the Expenses (in $) in France in 2007 to that in 2008?
Ensure brevity in your answer.  0.97. What is the ratio of the Expenses (in $) of Hungary in 2007 to that in 2008?
Provide a short and direct response. 0.88. What is the ratio of the Expenses (in $) of Norway in 2007 to that in 2008?
Make the answer very short. 0.93. What is the ratio of the Expenses (in $) of Poland in 2007 to that in 2008?
Offer a terse response. 0.98. What is the ratio of the Expenses (in $) in France in 2007 to that in 2009?
Give a very brief answer. 0.9. What is the ratio of the Expenses (in $) in Hungary in 2007 to that in 2009?
Make the answer very short. 0.85. What is the ratio of the Expenses (in $) of Norway in 2007 to that in 2009?
Ensure brevity in your answer.  0.84. What is the ratio of the Expenses (in $) of Poland in 2007 to that in 2009?
Make the answer very short. 1.33. What is the ratio of the Expenses (in $) in France in 2008 to that in 2009?
Your answer should be very brief. 0.93. What is the ratio of the Expenses (in $) in Hungary in 2008 to that in 2009?
Keep it short and to the point. 0.97. What is the ratio of the Expenses (in $) in Norway in 2008 to that in 2009?
Your answer should be compact. 0.9. What is the ratio of the Expenses (in $) in Poland in 2008 to that in 2009?
Provide a succinct answer. 1.36. What is the difference between the highest and the second highest Expenses (in $) of France?
Offer a terse response. 4.11e+09. What is the difference between the highest and the second highest Expenses (in $) in Hungary?
Offer a very short reply. 3.77e+1. What is the difference between the highest and the second highest Expenses (in $) in Norway?
Provide a succinct answer. 8.85e+09. What is the difference between the highest and the second highest Expenses (in $) of Poland?
Offer a very short reply. 7.43e+08. What is the difference between the highest and the lowest Expenses (in $) in France?
Provide a short and direct response. 1.18e+1. What is the difference between the highest and the lowest Expenses (in $) of Hungary?
Give a very brief answer. 5.03e+11. What is the difference between the highest and the lowest Expenses (in $) of Norway?
Offer a very short reply. 2.30e+1. What is the difference between the highest and the lowest Expenses (in $) in Poland?
Provide a short and direct response. 1.01e+1. 